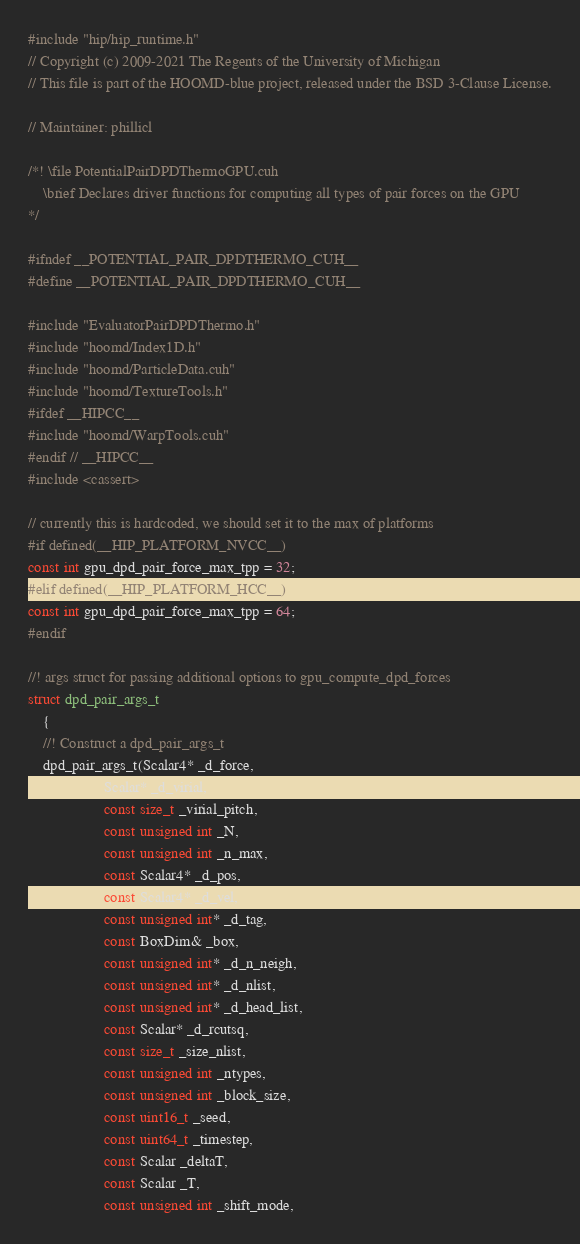Convert code to text. <code><loc_0><loc_0><loc_500><loc_500><_Cuda_>#include "hip/hip_runtime.h"
// Copyright (c) 2009-2021 The Regents of the University of Michigan
// This file is part of the HOOMD-blue project, released under the BSD 3-Clause License.

// Maintainer: phillicl

/*! \file PotentialPairDPDThermoGPU.cuh
    \brief Declares driver functions for computing all types of pair forces on the GPU
*/

#ifndef __POTENTIAL_PAIR_DPDTHERMO_CUH__
#define __POTENTIAL_PAIR_DPDTHERMO_CUH__

#include "EvaluatorPairDPDThermo.h"
#include "hoomd/Index1D.h"
#include "hoomd/ParticleData.cuh"
#include "hoomd/TextureTools.h"
#ifdef __HIPCC__
#include "hoomd/WarpTools.cuh"
#endif // __HIPCC__
#include <cassert>

// currently this is hardcoded, we should set it to the max of platforms
#if defined(__HIP_PLATFORM_NVCC__)
const int gpu_dpd_pair_force_max_tpp = 32;
#elif defined(__HIP_PLATFORM_HCC__)
const int gpu_dpd_pair_force_max_tpp = 64;
#endif

//! args struct for passing additional options to gpu_compute_dpd_forces
struct dpd_pair_args_t
    {
    //! Construct a dpd_pair_args_t
    dpd_pair_args_t(Scalar4* _d_force,
                    Scalar* _d_virial,
                    const size_t _virial_pitch,
                    const unsigned int _N,
                    const unsigned int _n_max,
                    const Scalar4* _d_pos,
                    const Scalar4* _d_vel,
                    const unsigned int* _d_tag,
                    const BoxDim& _box,
                    const unsigned int* _d_n_neigh,
                    const unsigned int* _d_nlist,
                    const unsigned int* _d_head_list,
                    const Scalar* _d_rcutsq,
                    const size_t _size_nlist,
                    const unsigned int _ntypes,
                    const unsigned int _block_size,
                    const uint16_t _seed,
                    const uint64_t _timestep,
                    const Scalar _deltaT,
                    const Scalar _T,
                    const unsigned int _shift_mode,</code> 